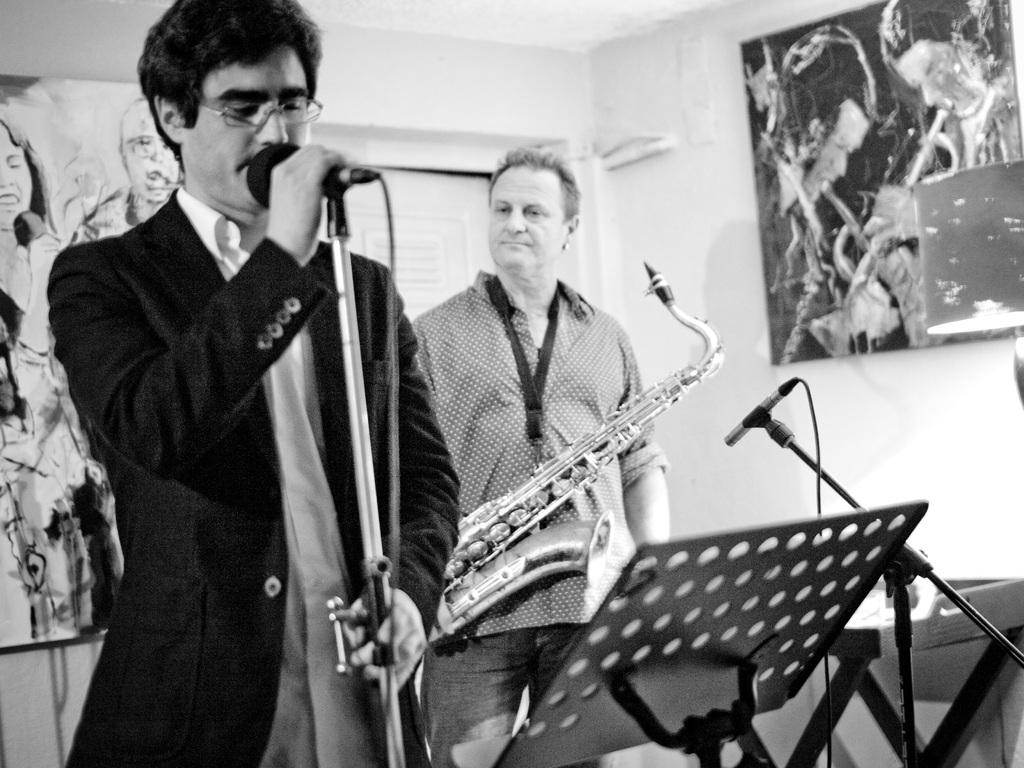What is the main subject of the image? The main subject of the image is a man in front of a mic. Can you describe the man's surroundings? There is another man in the image, and he is holding a musical instrument. There is also a wall in the background with two arts on it. How many sisters are present in the image? There is no mention of sisters in the image, so we cannot determine their presence. 